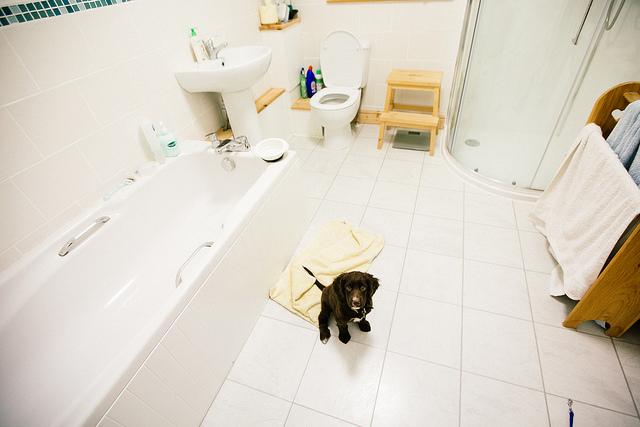What color are the tiles on the wall?
Short answer required. White. What room is this?
Give a very brief answer. Bathroom. What kind of dog is that?
Write a very short answer. Lab. 